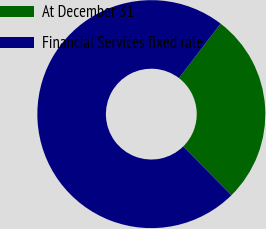<chart> <loc_0><loc_0><loc_500><loc_500><pie_chart><fcel>At December 31<fcel>Financial Services fixed rate<nl><fcel>27.2%<fcel>72.8%<nl></chart> 